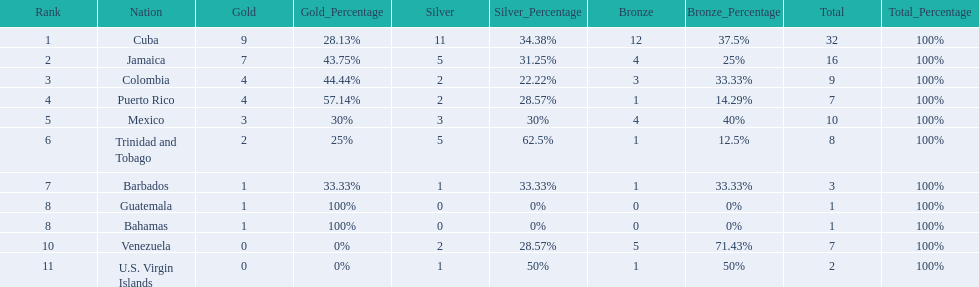Number of teams above 9 medals 3. 